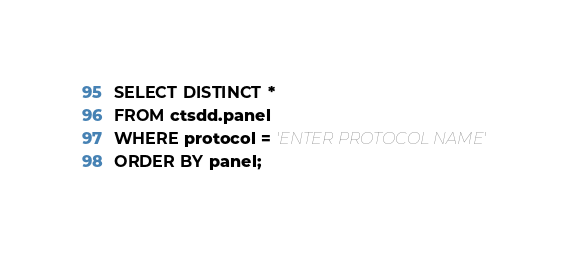<code> <loc_0><loc_0><loc_500><loc_500><_SQL_>SELECT DISTINCT *
FROM ctsdd.panel
WHERE protocol = 'ENTER PROTOCOL NAME'
ORDER BY panel;
</code> 